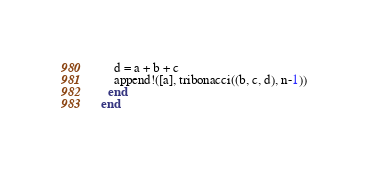Convert code to text. <code><loc_0><loc_0><loc_500><loc_500><_Julia_>    d = a + b + c
    append!([a], tribonacci((b, c, d), n-1))
  end
end

</code> 